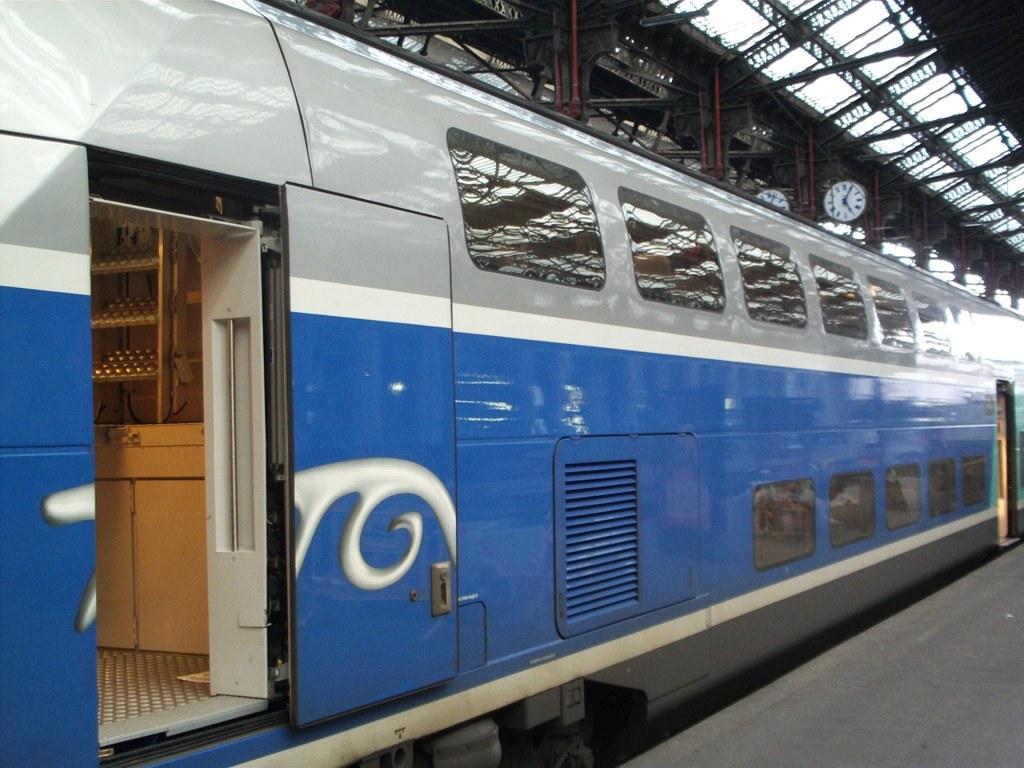Could you give a brief overview of what you see in this image? The picture is taken in a railway station. In the foreground we can see a train and platform. At the top there are iron frames, ceiling and a clock. 